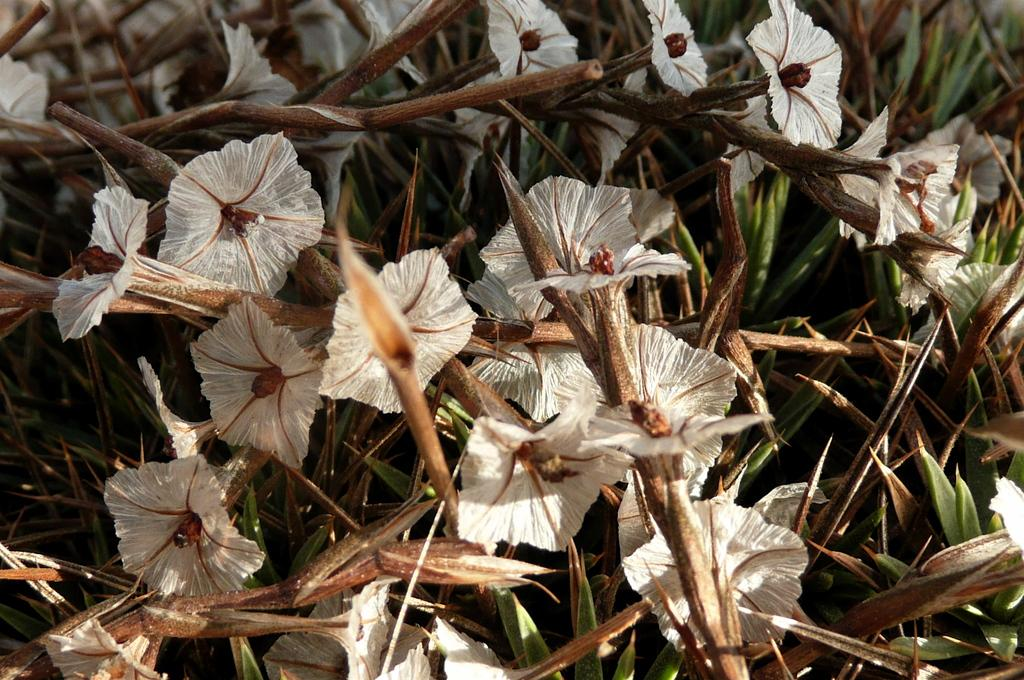What type of plants are in the image? There are flowers in the image. What color are the flowers? The flowers are white in color. What other colors can be seen in the image? There are brown and green color objects in the image. How many eyes can be seen on the flowers in the image? There are no eyes visible on the flowers in the image, as flowers do not have eyes. 